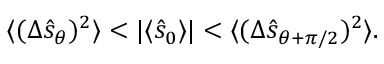<formula> <loc_0><loc_0><loc_500><loc_500>\begin{array} { r } { \langle ( \Delta \hat { s } _ { \theta } ) ^ { 2 } \rangle < | \langle \hat { s } _ { 0 } \rangle | < \langle ( \Delta \hat { s } _ { \theta + \pi / 2 } ) ^ { 2 } \rangle . } \end{array}</formula> 